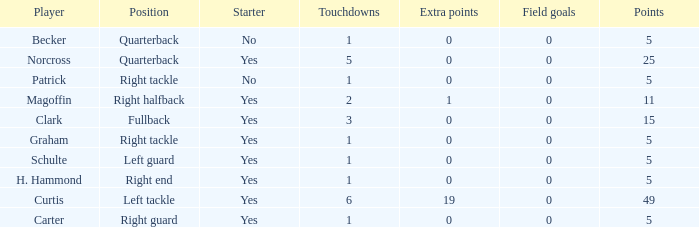Name the most touchdowns for norcross 5.0. 